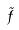Convert formula to latex. <formula><loc_0><loc_0><loc_500><loc_500>\tilde { f }</formula> 